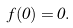<formula> <loc_0><loc_0><loc_500><loc_500>f ( 0 ) = 0 .</formula> 